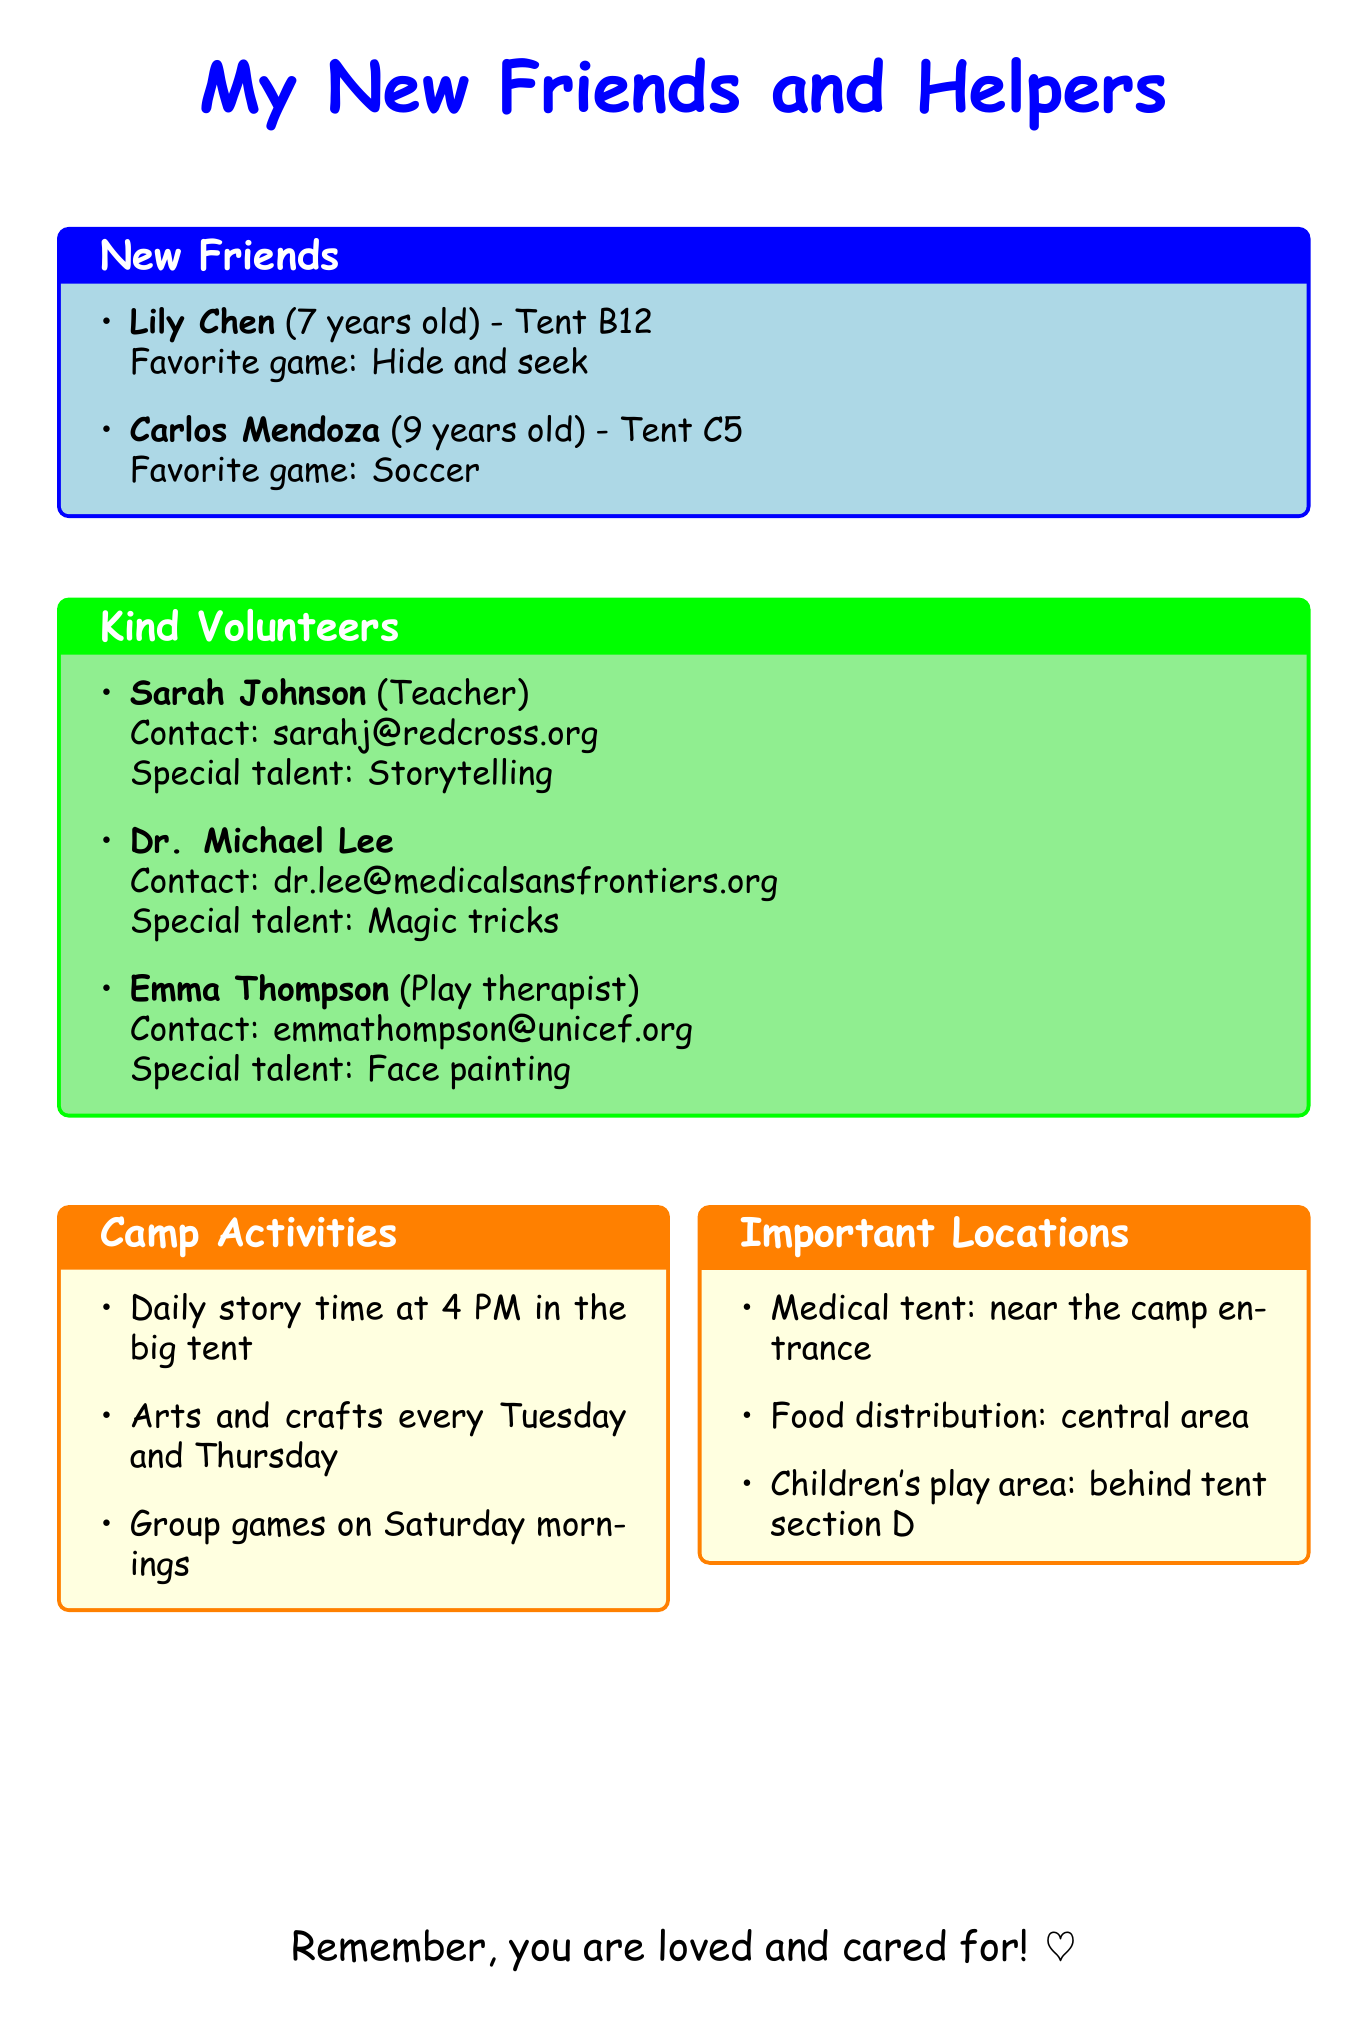What is the name of my new friend in tent B12? The name of the new friend in tent B12 is listed in the new friends section of the document.
Answer: Lily Chen How old is Carlos Mendoza? Carlos Mendoza's age is specified in the new friends section of the document.
Answer: 9 What is the special talent of Sarah Johnson? Sarah Johnson's special talent is mentioned under kind volunteers in the document.
Answer: Storytelling Which volunteer is a doctor? The document specifies that one of the volunteers is a doctor, providing their name in the kind volunteers section.
Answer: Michael Lee What activity happens every Tuesday? Daily activities are described in a section of the document, indicating what happens on Tuesdays.
Answer: Arts and crafts What is the contact email for Emma Thompson? Emma Thompson's contact email is provided in the kind volunteers section.
Answer: emmathompson@unicef.org Where is the children's play area located? The location of the children's play area is detailed under important locations in the document.
Answer: Behind tent section D What is Lily's favorite game? The favorite game of Lily is mentioned in the new friends section of the document.
Answer: Hide and seek What is the role of Michael Lee? Michael Lee's role is specified in the kind volunteers section of the document.
Answer: Doctor 